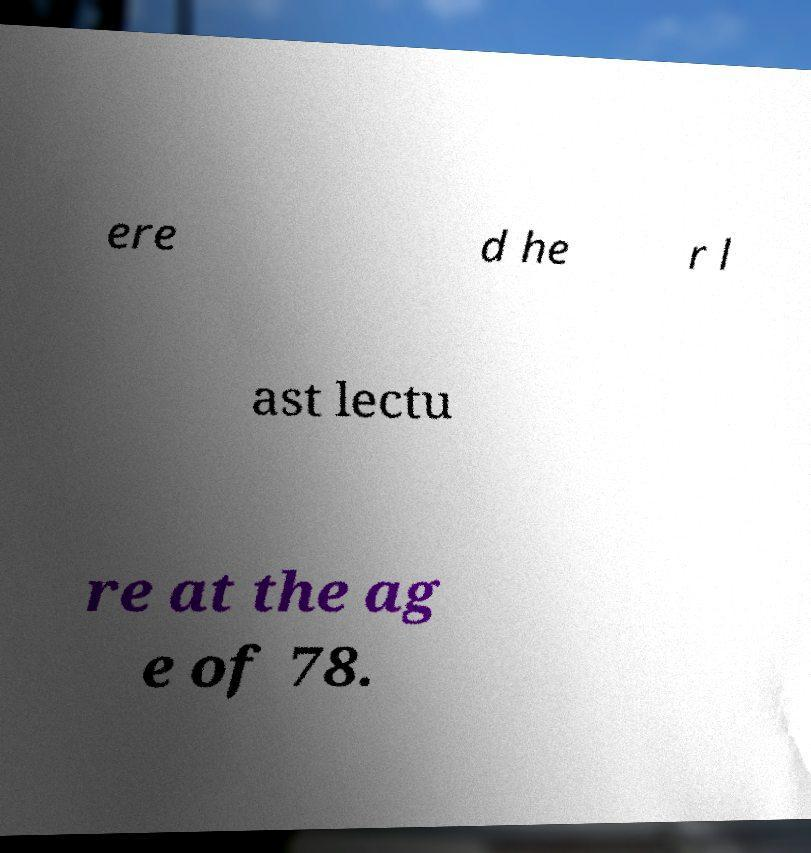Please read and relay the text visible in this image. What does it say? ere d he r l ast lectu re at the ag e of 78. 